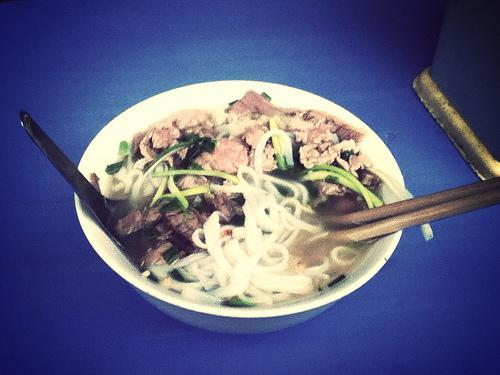Question: what color is the tablecloth?
Choices:
A. White.
B. Red.
C. Blue.
D. Black.
Answer with the letter. Answer: C Question: how many utensils are in the dish?
Choices:
A. Two.
B. Three.
C. Four.
D. Five.
Answer with the letter. Answer: B Question: where are the noodles?
Choices:
A. In the bowl.
B. In the microwave.
C. In the kitchen.
D. In the container.
Answer with the letter. Answer: A Question: what color are the vegetables?
Choices:
A. Yellow.
B. Brown.
C. Green.
D. Red.
Answer with the letter. Answer: C 